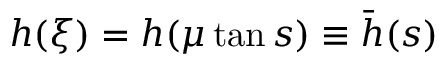<formula> <loc_0><loc_0><loc_500><loc_500>h ( \xi ) = h ( \mu \tan s ) \equiv \bar { h } ( s )</formula> 